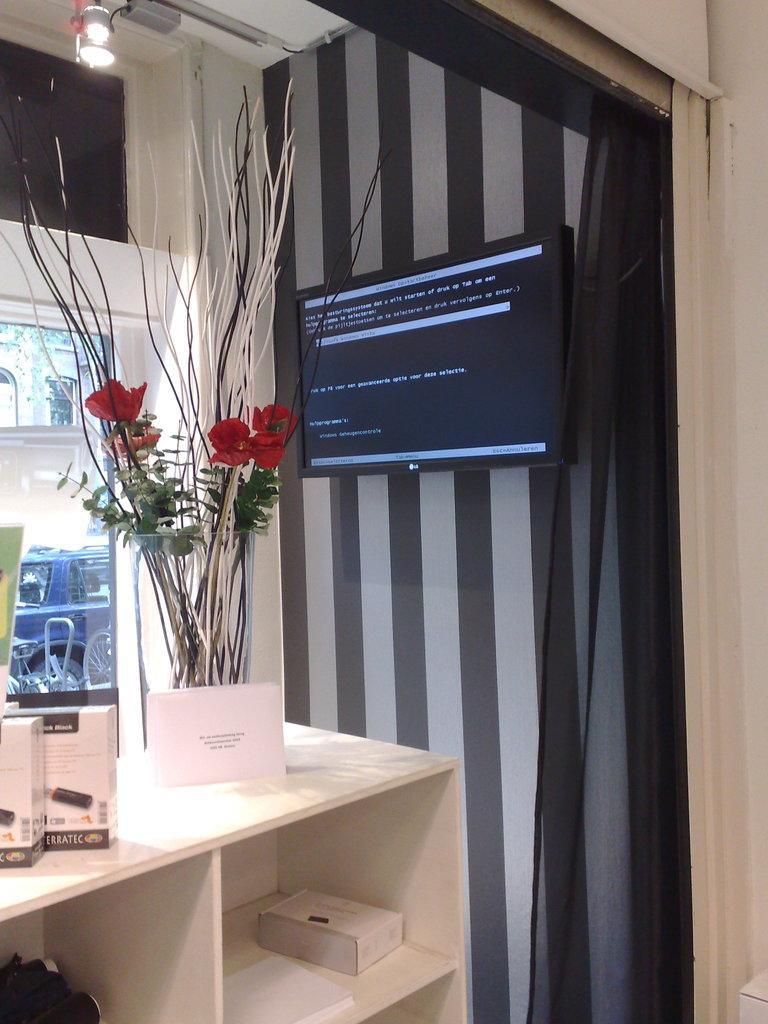Describe this image in one or two sentences. In this picture we can see table and on table we have flower vase, boxes and below it there are racks and in background we can see television to wall, glass, light. 